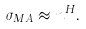Convert formula to latex. <formula><loc_0><loc_0><loc_500><loc_500>\sigma _ { M A } \approx n ^ { H } .</formula> 